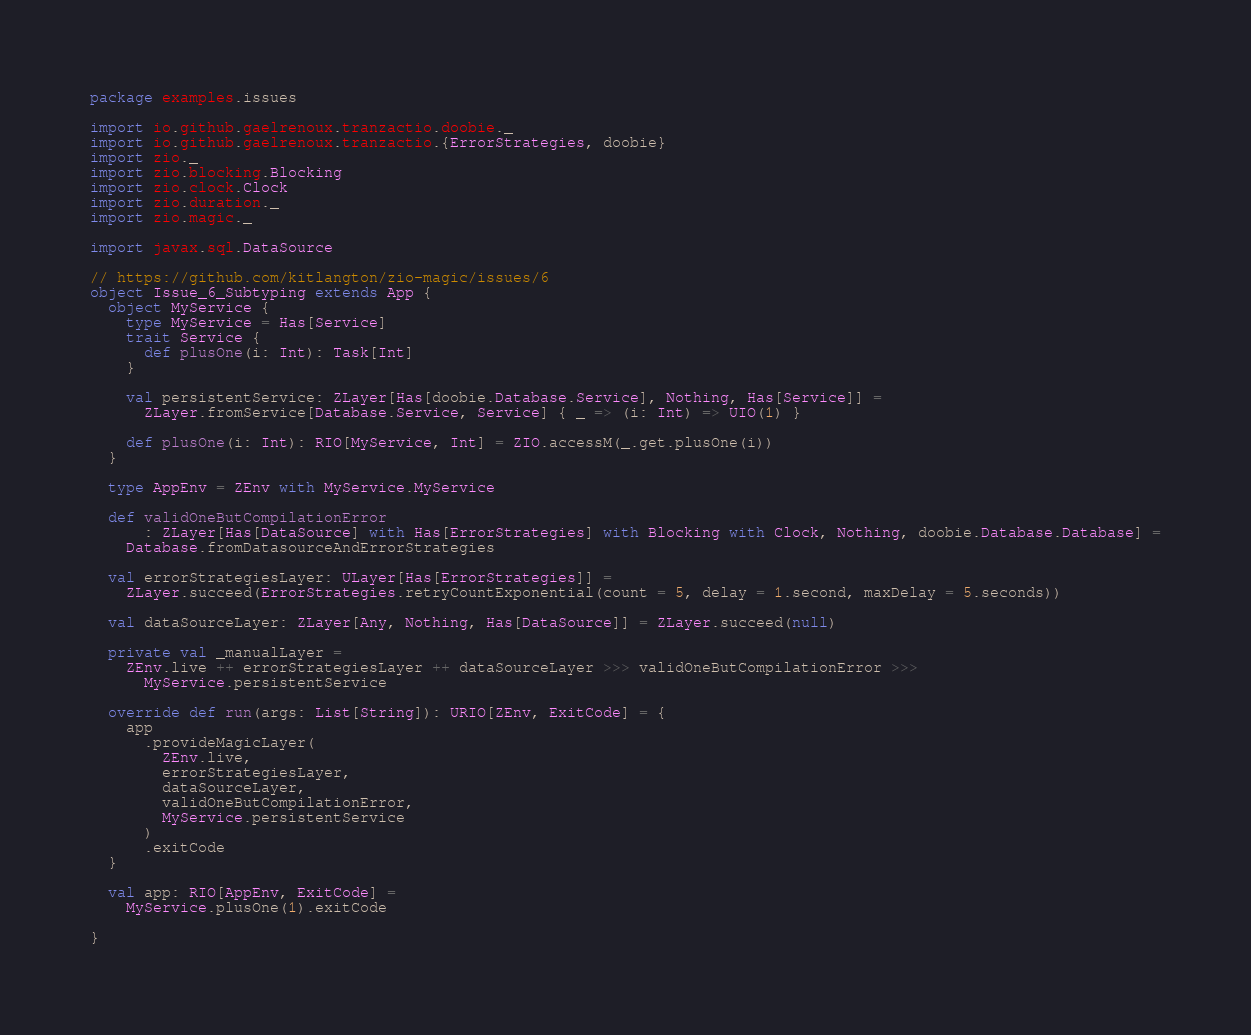<code> <loc_0><loc_0><loc_500><loc_500><_Scala_>package examples.issues

import io.github.gaelrenoux.tranzactio.doobie._
import io.github.gaelrenoux.tranzactio.{ErrorStrategies, doobie}
import zio._
import zio.blocking.Blocking
import zio.clock.Clock
import zio.duration._
import zio.magic._

import javax.sql.DataSource

// https://github.com/kitlangton/zio-magic/issues/6
object Issue_6_Subtyping extends App {
  object MyService {
    type MyService = Has[Service]
    trait Service {
      def plusOne(i: Int): Task[Int]
    }

    val persistentService: ZLayer[Has[doobie.Database.Service], Nothing, Has[Service]] =
      ZLayer.fromService[Database.Service, Service] { _ => (i: Int) => UIO(1) }

    def plusOne(i: Int): RIO[MyService, Int] = ZIO.accessM(_.get.plusOne(i))
  }

  type AppEnv = ZEnv with MyService.MyService

  def validOneButCompilationError
      : ZLayer[Has[DataSource] with Has[ErrorStrategies] with Blocking with Clock, Nothing, doobie.Database.Database] =
    Database.fromDatasourceAndErrorStrategies

  val errorStrategiesLayer: ULayer[Has[ErrorStrategies]] =
    ZLayer.succeed(ErrorStrategies.retryCountExponential(count = 5, delay = 1.second, maxDelay = 5.seconds))

  val dataSourceLayer: ZLayer[Any, Nothing, Has[DataSource]] = ZLayer.succeed(null)

  private val _manualLayer =
    ZEnv.live ++ errorStrategiesLayer ++ dataSourceLayer >>> validOneButCompilationError >>>
      MyService.persistentService

  override def run(args: List[String]): URIO[ZEnv, ExitCode] = {
    app
      .provideMagicLayer(
        ZEnv.live,
        errorStrategiesLayer,
        dataSourceLayer,
        validOneButCompilationError,
        MyService.persistentService
      )
      .exitCode
  }

  val app: RIO[AppEnv, ExitCode] =
    MyService.plusOne(1).exitCode

}
</code> 